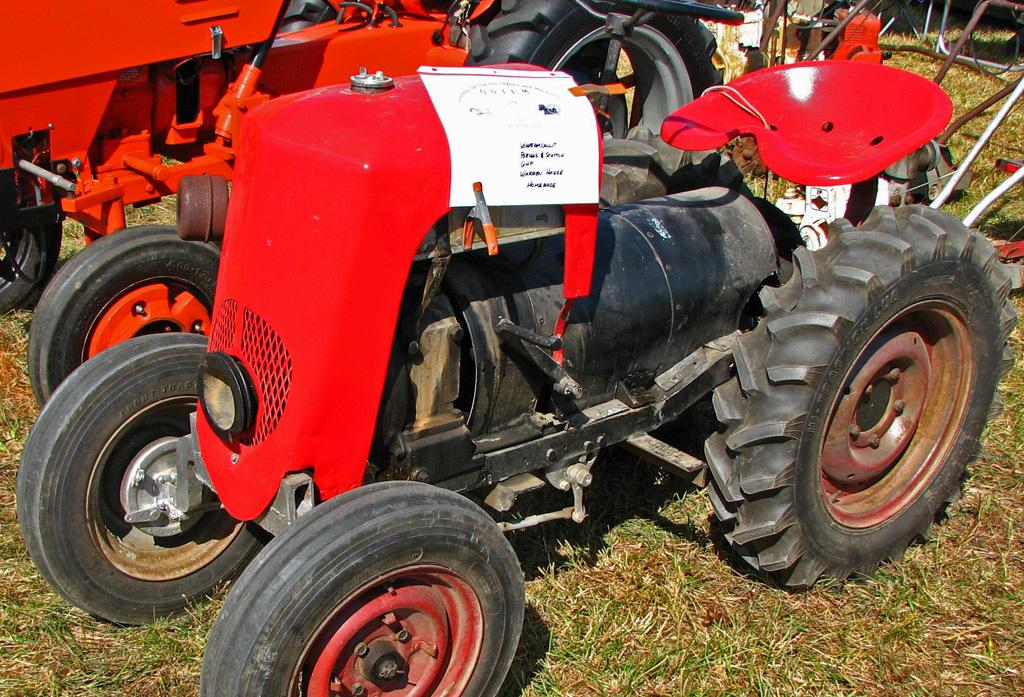What type of vehicles are in the image? There are tractors in the image. Where are the tractors located? The tractors are on the grass. What is present on the front tractor? There is a paper with text on the front tractor. What language is spoken on the island depicted in the image? There is no island present in the image, so it is not possible to determine the language spoken there. 